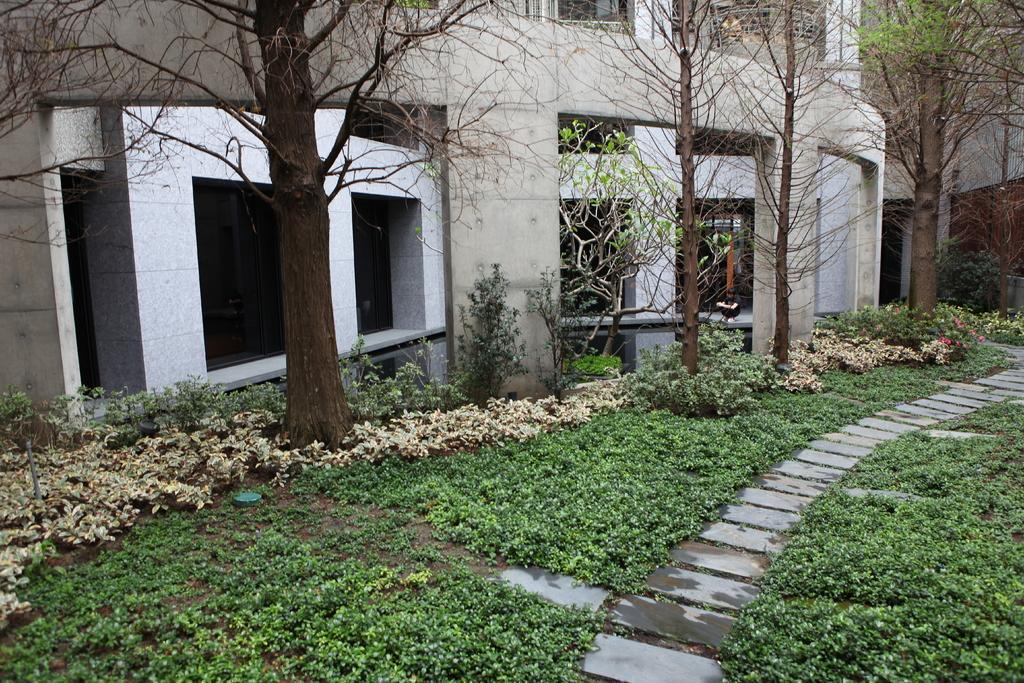How would you summarize this image in a sentence or two? In the center of the image we can see one building, pillars, trees, plants, grass, stones and a few other objects. 